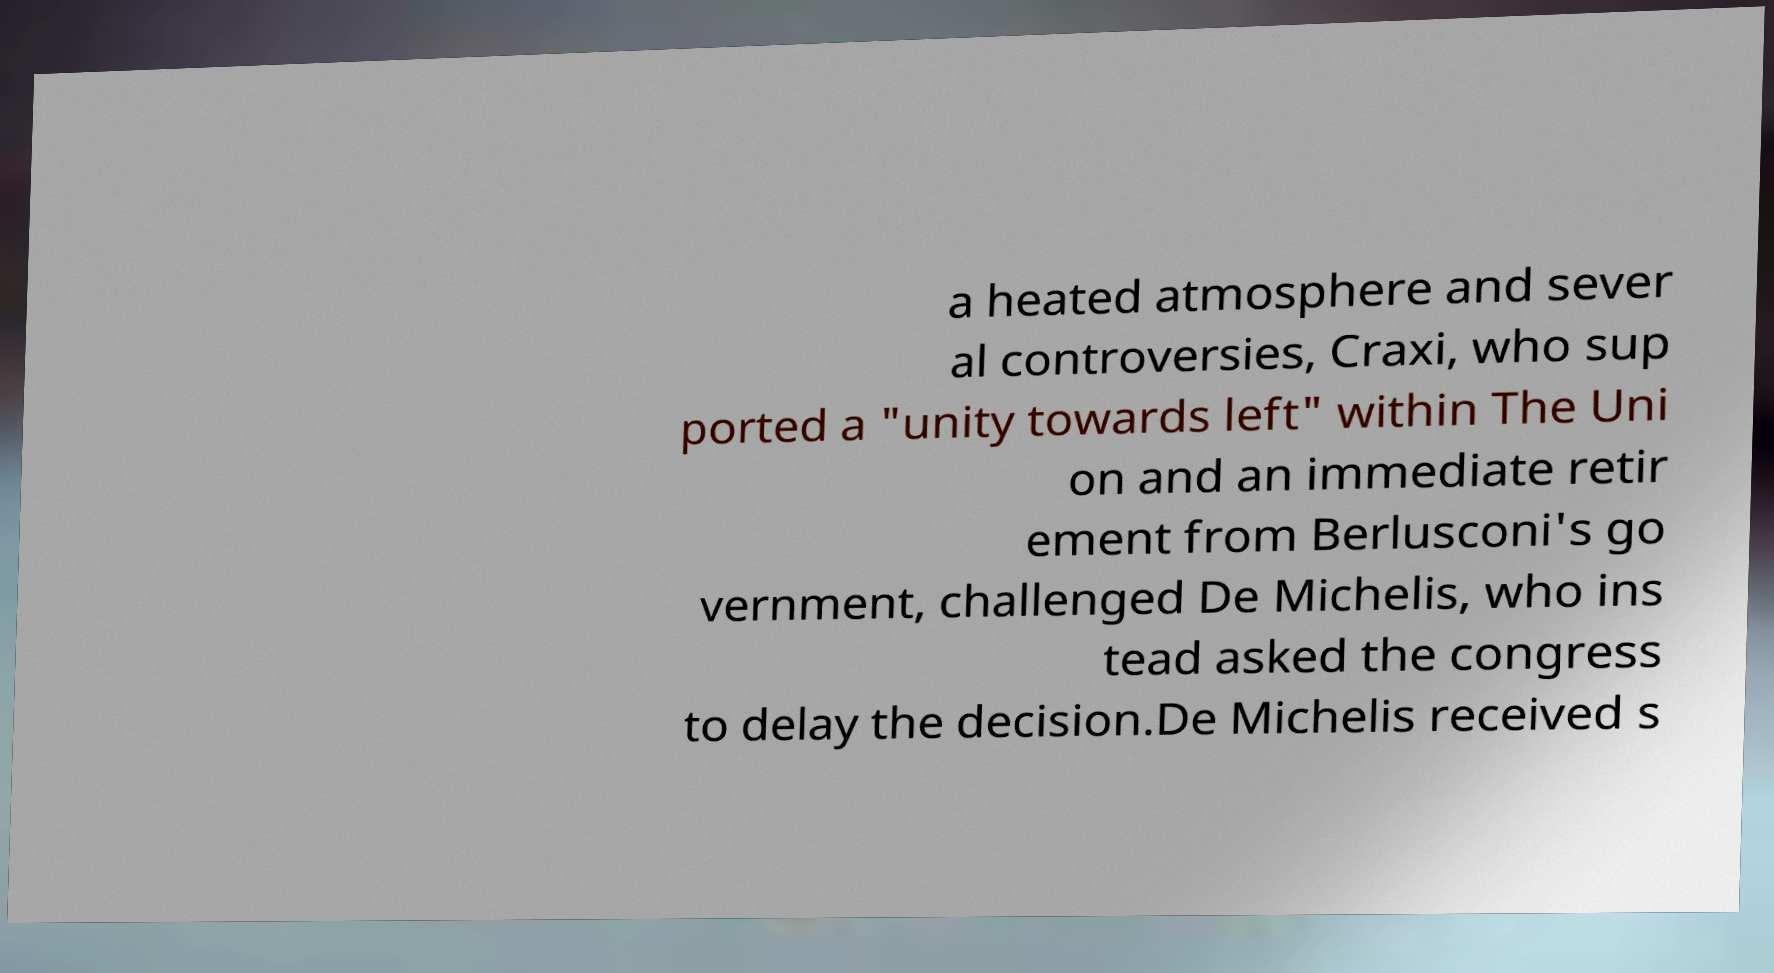Could you extract and type out the text from this image? a heated atmosphere and sever al controversies, Craxi, who sup ported a "unity towards left" within The Uni on and an immediate retir ement from Berlusconi's go vernment, challenged De Michelis, who ins tead asked the congress to delay the decision.De Michelis received s 